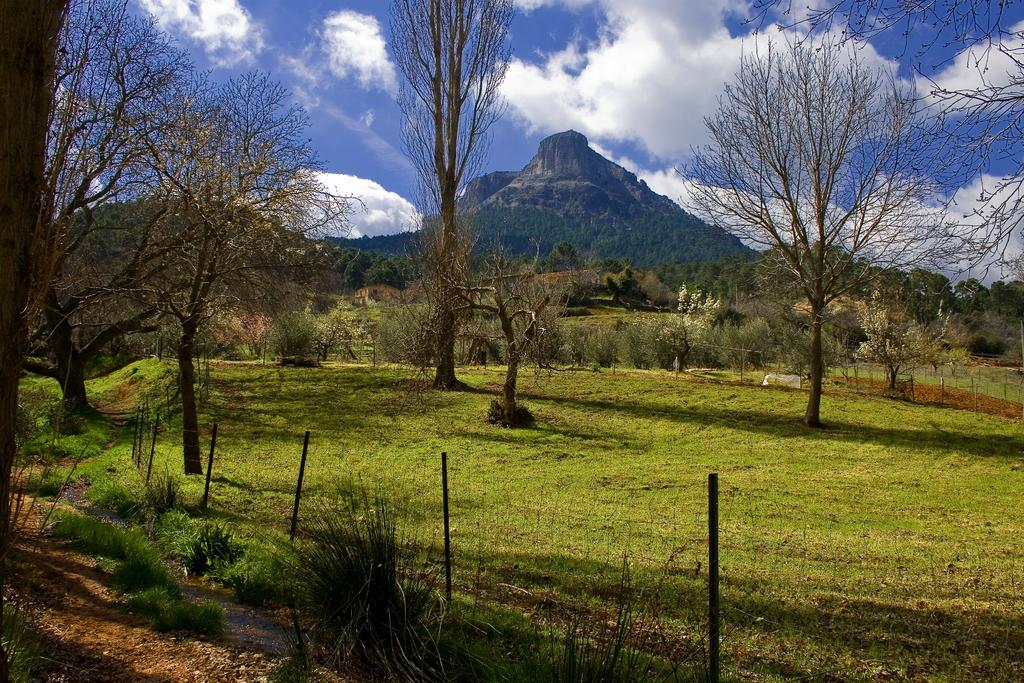What type of natural landform can be seen in the image? There are mountains in the image. What type of vegetation is present in the image? There are trees in the image. What part of the sky is visible in the image? The sky is visible in the image. What can be seen in the sky in the image? Clouds are present in the sky. What type of ground cover is at the bottom of the image? There is grass at the bottom of the image. What type of barrier is present in the image? There is fencing in the image. What type of medical treatment is being administered in the image? There is no medical treatment present in the image; it features mountains, trees, sky, clouds, grass, and fencing. What type of religious ceremony is taking place in the image? There is no religious ceremony present in the image; it features mountains, trees, sky, clouds, grass, and fencing. 